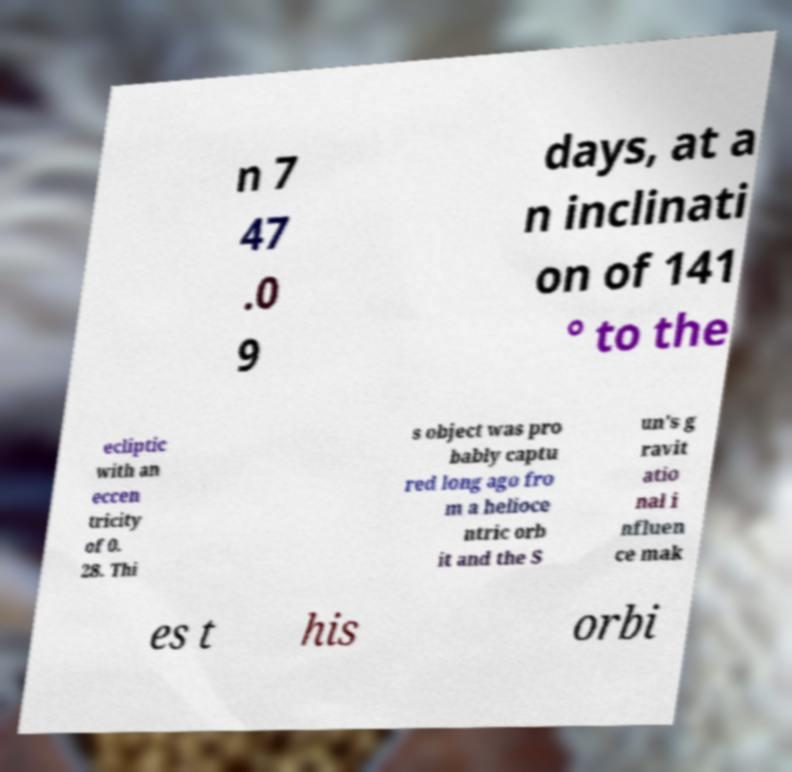Can you read and provide the text displayed in the image?This photo seems to have some interesting text. Can you extract and type it out for me? n 7 47 .0 9 days, at a n inclinati on of 141 ° to the ecliptic with an eccen tricity of 0. 28. Thi s object was pro bably captu red long ago fro m a helioce ntric orb it and the S un's g ravit atio nal i nfluen ce mak es t his orbi 